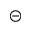<formula> <loc_0><loc_0><loc_500><loc_500>\circleddash</formula> 